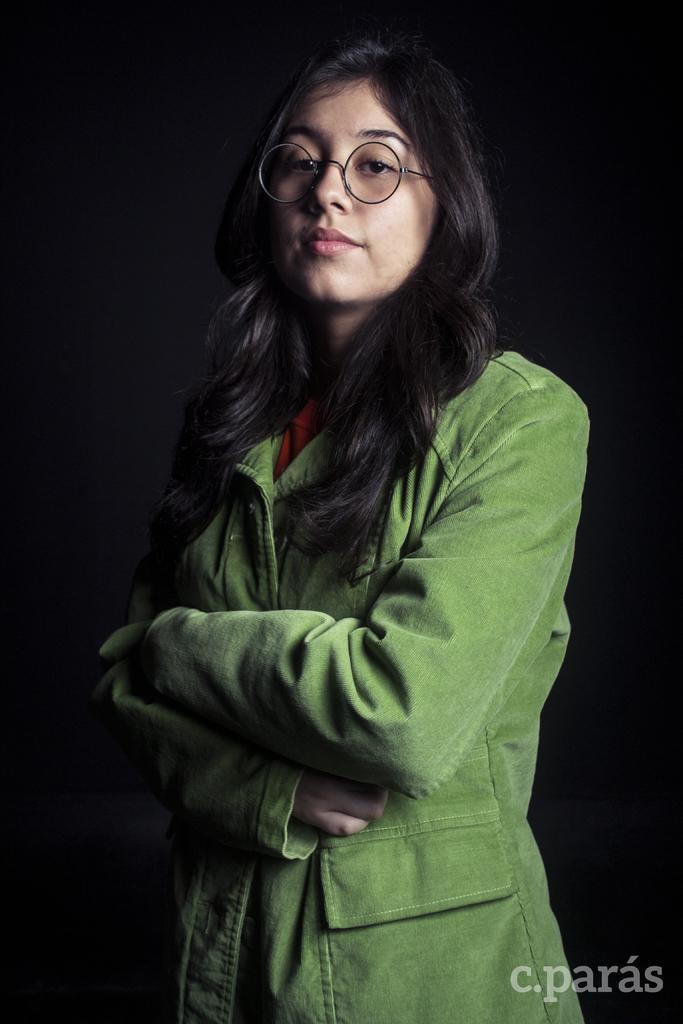Please provide a concise description of this image. In this picture there is a woman with green color jacket is standing. At the back there is a black background. At the bottom right there is text. 